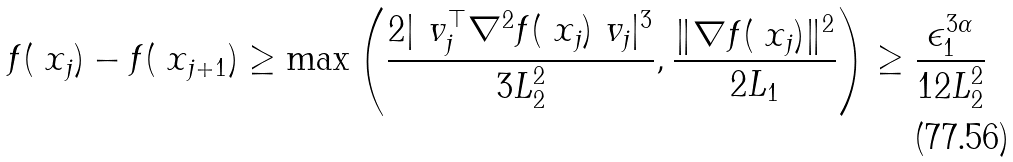<formula> <loc_0><loc_0><loc_500><loc_500>f ( \ x _ { j } ) - f ( \ x _ { j + 1 } ) \geq \max \left ( \frac { 2 | \ v _ { j } ^ { \top } \nabla ^ { 2 } f ( \ x _ { j } ) \ v _ { j } | ^ { 3 } } { 3 L _ { 2 } ^ { 2 } } , \frac { \| \nabla f ( \ x _ { j } ) \| ^ { 2 } } { 2 L _ { 1 } } \right ) \geq \frac { \epsilon _ { 1 } ^ { 3 \alpha } } { 1 2 L _ { 2 } ^ { 2 } }</formula> 